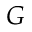<formula> <loc_0><loc_0><loc_500><loc_500>G</formula> 